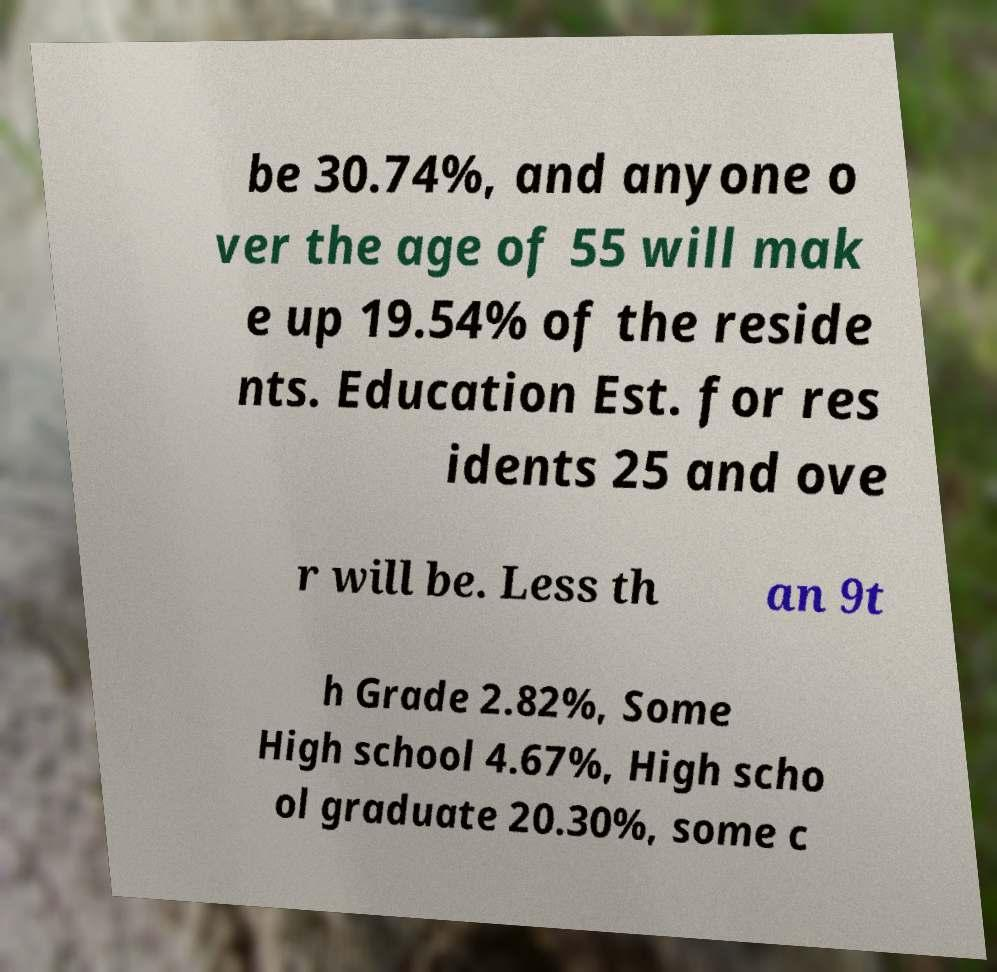For documentation purposes, I need the text within this image transcribed. Could you provide that? be 30.74%, and anyone o ver the age of 55 will mak e up 19.54% of the reside nts. Education Est. for res idents 25 and ove r will be. Less th an 9t h Grade 2.82%, Some High school 4.67%, High scho ol graduate 20.30%, some c 